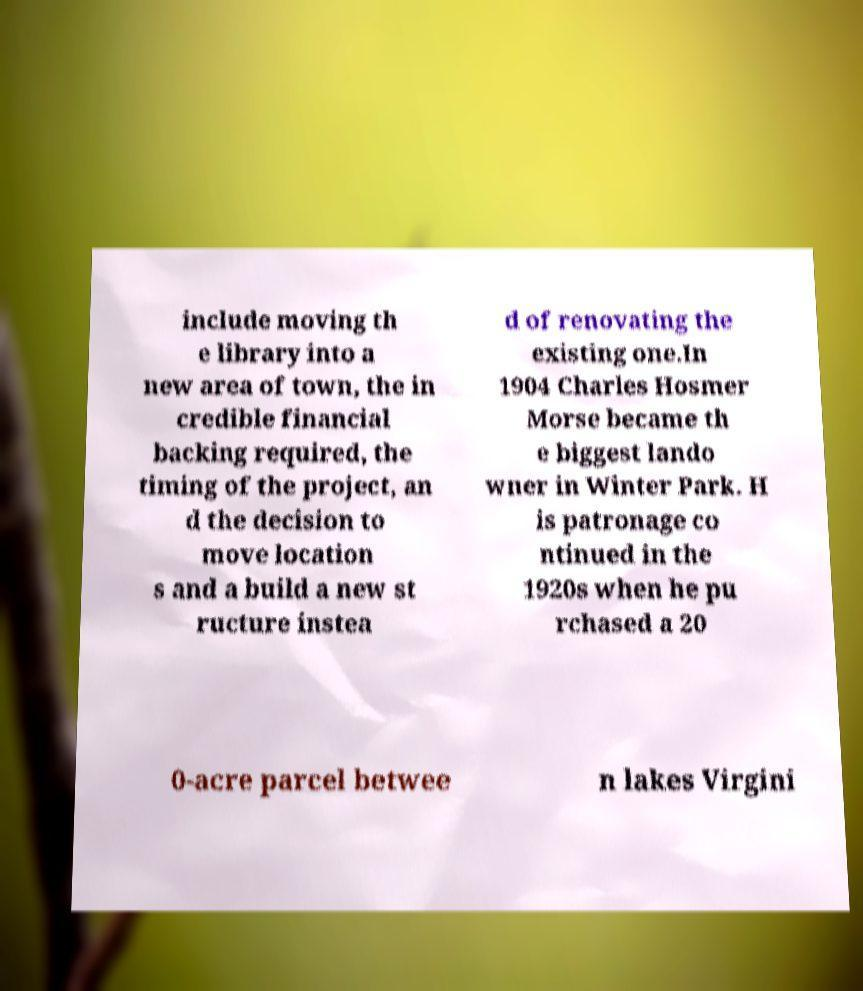What messages or text are displayed in this image? I need them in a readable, typed format. include moving th e library into a new area of town, the in credible financial backing required, the timing of the project, an d the decision to move location s and a build a new st ructure instea d of renovating the existing one.In 1904 Charles Hosmer Morse became th e biggest lando wner in Winter Park. H is patronage co ntinued in the 1920s when he pu rchased a 20 0-acre parcel betwee n lakes Virgini 